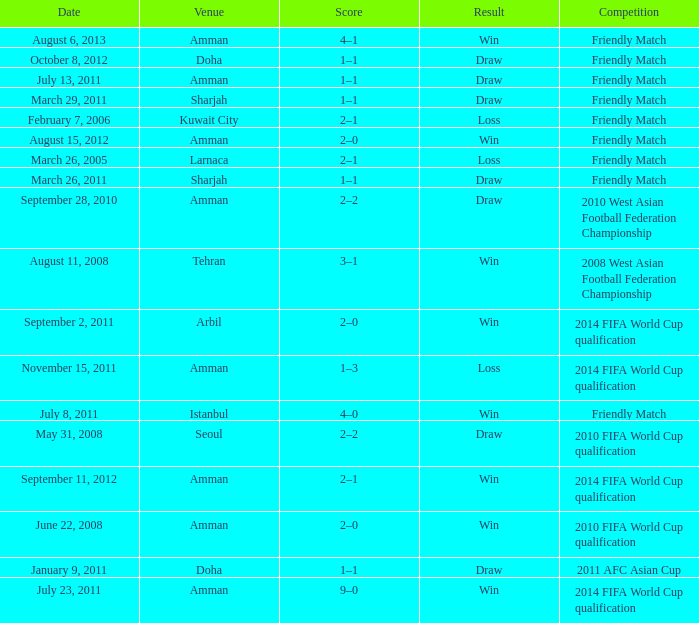During the loss on march 26, 2005, what was the venue where the match was played? Larnaca. 